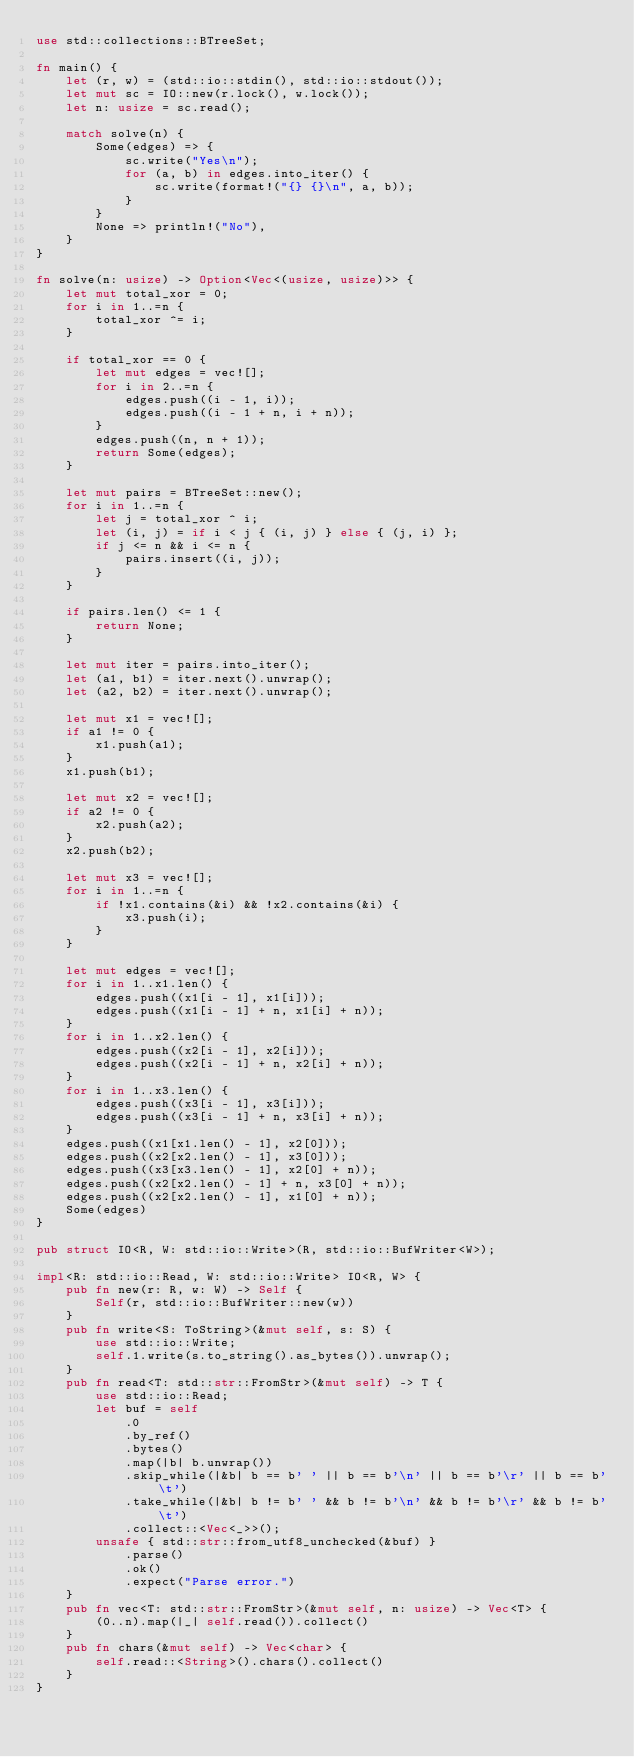<code> <loc_0><loc_0><loc_500><loc_500><_Rust_>use std::collections::BTreeSet;

fn main() {
    let (r, w) = (std::io::stdin(), std::io::stdout());
    let mut sc = IO::new(r.lock(), w.lock());
    let n: usize = sc.read();

    match solve(n) {
        Some(edges) => {
            sc.write("Yes\n");
            for (a, b) in edges.into_iter() {
                sc.write(format!("{} {}\n", a, b));
            }
        }
        None => println!("No"),
    }
}

fn solve(n: usize) -> Option<Vec<(usize, usize)>> {
    let mut total_xor = 0;
    for i in 1..=n {
        total_xor ^= i;
    }

    if total_xor == 0 {
        let mut edges = vec![];
        for i in 2..=n {
            edges.push((i - 1, i));
            edges.push((i - 1 + n, i + n));
        }
        edges.push((n, n + 1));
        return Some(edges);
    }

    let mut pairs = BTreeSet::new();
    for i in 1..=n {
        let j = total_xor ^ i;
        let (i, j) = if i < j { (i, j) } else { (j, i) };
        if j <= n && i <= n {
            pairs.insert((i, j));
        }
    }

    if pairs.len() <= 1 {
        return None;
    }

    let mut iter = pairs.into_iter();
    let (a1, b1) = iter.next().unwrap();
    let (a2, b2) = iter.next().unwrap();

    let mut x1 = vec![];
    if a1 != 0 {
        x1.push(a1);
    }
    x1.push(b1);

    let mut x2 = vec![];
    if a2 != 0 {
        x2.push(a2);
    }
    x2.push(b2);

    let mut x3 = vec![];
    for i in 1..=n {
        if !x1.contains(&i) && !x2.contains(&i) {
            x3.push(i);
        }
    }

    let mut edges = vec![];
    for i in 1..x1.len() {
        edges.push((x1[i - 1], x1[i]));
        edges.push((x1[i - 1] + n, x1[i] + n));
    }
    for i in 1..x2.len() {
        edges.push((x2[i - 1], x2[i]));
        edges.push((x2[i - 1] + n, x2[i] + n));
    }
    for i in 1..x3.len() {
        edges.push((x3[i - 1], x3[i]));
        edges.push((x3[i - 1] + n, x3[i] + n));
    }
    edges.push((x1[x1.len() - 1], x2[0]));
    edges.push((x2[x2.len() - 1], x3[0]));
    edges.push((x3[x3.len() - 1], x2[0] + n));
    edges.push((x2[x2.len() - 1] + n, x3[0] + n));
    edges.push((x2[x2.len() - 1], x1[0] + n));
    Some(edges)
}

pub struct IO<R, W: std::io::Write>(R, std::io::BufWriter<W>);

impl<R: std::io::Read, W: std::io::Write> IO<R, W> {
    pub fn new(r: R, w: W) -> Self {
        Self(r, std::io::BufWriter::new(w))
    }
    pub fn write<S: ToString>(&mut self, s: S) {
        use std::io::Write;
        self.1.write(s.to_string().as_bytes()).unwrap();
    }
    pub fn read<T: std::str::FromStr>(&mut self) -> T {
        use std::io::Read;
        let buf = self
            .0
            .by_ref()
            .bytes()
            .map(|b| b.unwrap())
            .skip_while(|&b| b == b' ' || b == b'\n' || b == b'\r' || b == b'\t')
            .take_while(|&b| b != b' ' && b != b'\n' && b != b'\r' && b != b'\t')
            .collect::<Vec<_>>();
        unsafe { std::str::from_utf8_unchecked(&buf) }
            .parse()
            .ok()
            .expect("Parse error.")
    }
    pub fn vec<T: std::str::FromStr>(&mut self, n: usize) -> Vec<T> {
        (0..n).map(|_| self.read()).collect()
    }
    pub fn chars(&mut self) -> Vec<char> {
        self.read::<String>().chars().collect()
    }
}
</code> 